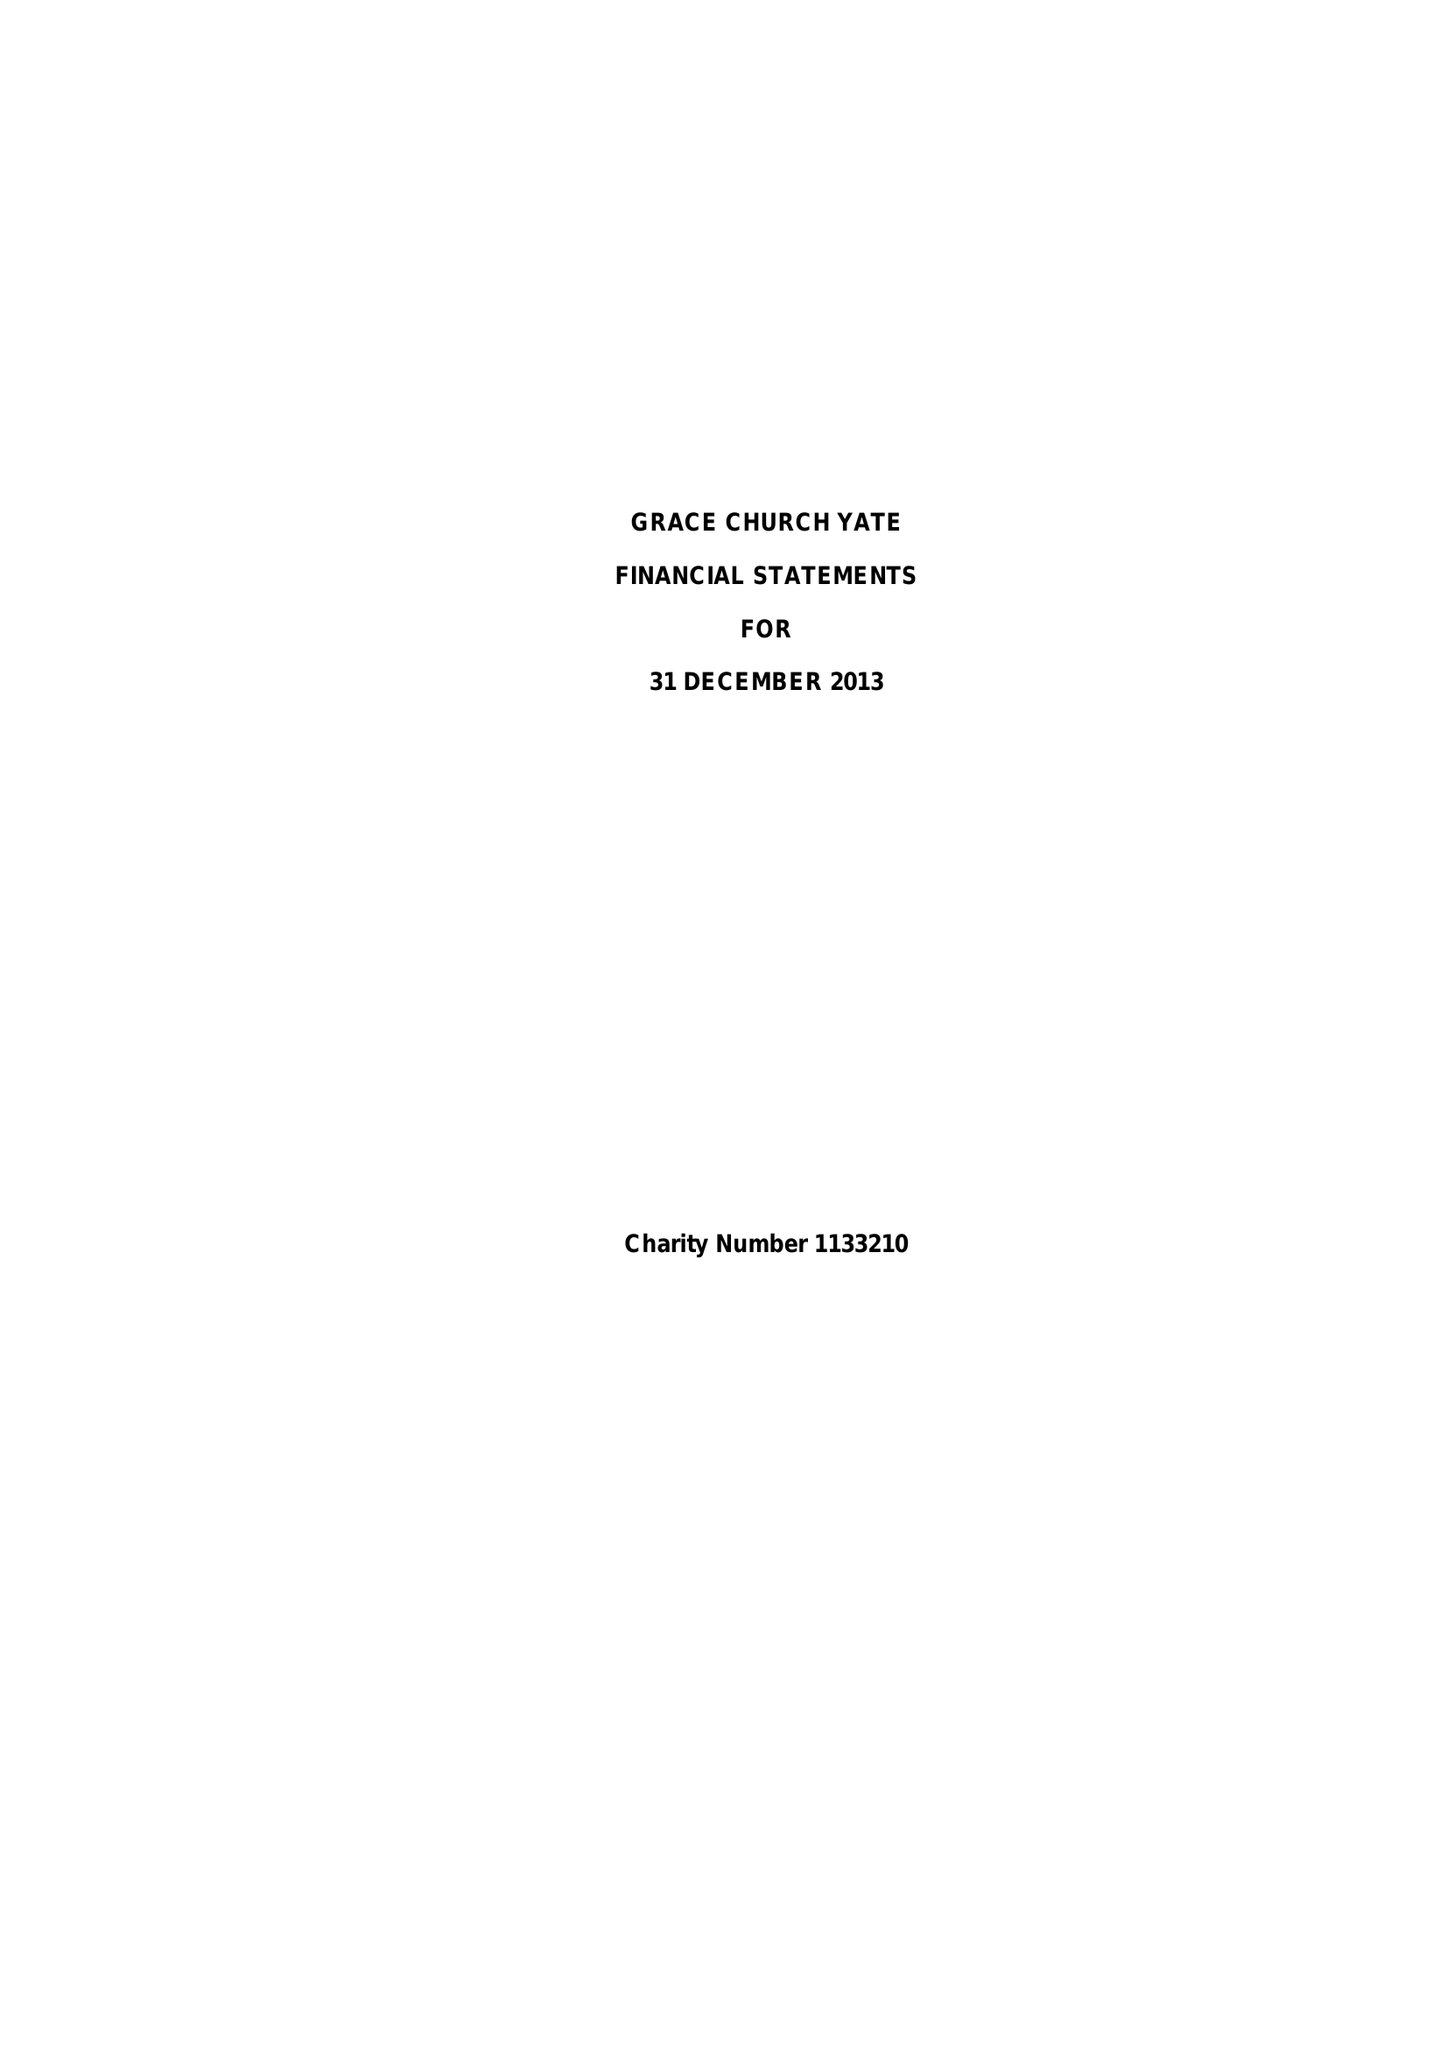What is the value for the charity_number?
Answer the question using a single word or phrase. 1133210 